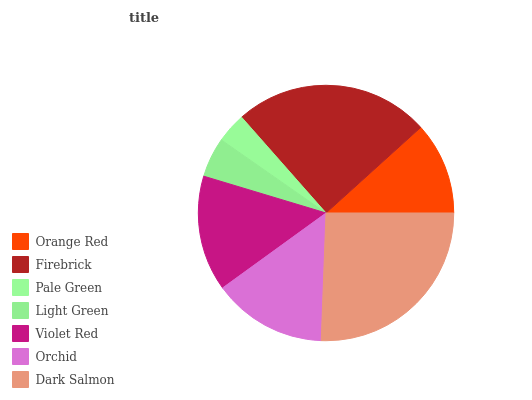Is Pale Green the minimum?
Answer yes or no. Yes. Is Dark Salmon the maximum?
Answer yes or no. Yes. Is Firebrick the minimum?
Answer yes or no. No. Is Firebrick the maximum?
Answer yes or no. No. Is Firebrick greater than Orange Red?
Answer yes or no. Yes. Is Orange Red less than Firebrick?
Answer yes or no. Yes. Is Orange Red greater than Firebrick?
Answer yes or no. No. Is Firebrick less than Orange Red?
Answer yes or no. No. Is Orchid the high median?
Answer yes or no. Yes. Is Orchid the low median?
Answer yes or no. Yes. Is Violet Red the high median?
Answer yes or no. No. Is Firebrick the low median?
Answer yes or no. No. 